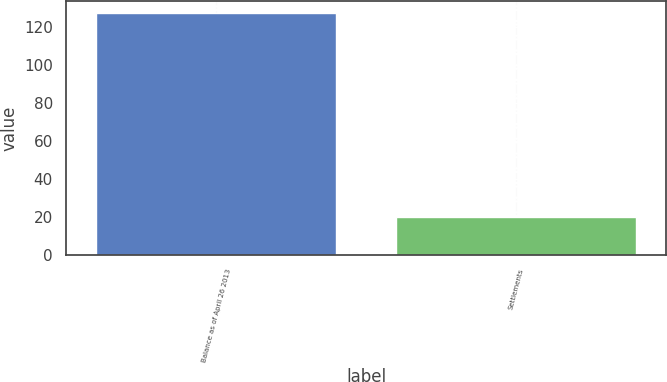Convert chart to OTSL. <chart><loc_0><loc_0><loc_500><loc_500><bar_chart><fcel>Balance as of April 26 2013<fcel>Settlements<nl><fcel>127<fcel>20<nl></chart> 